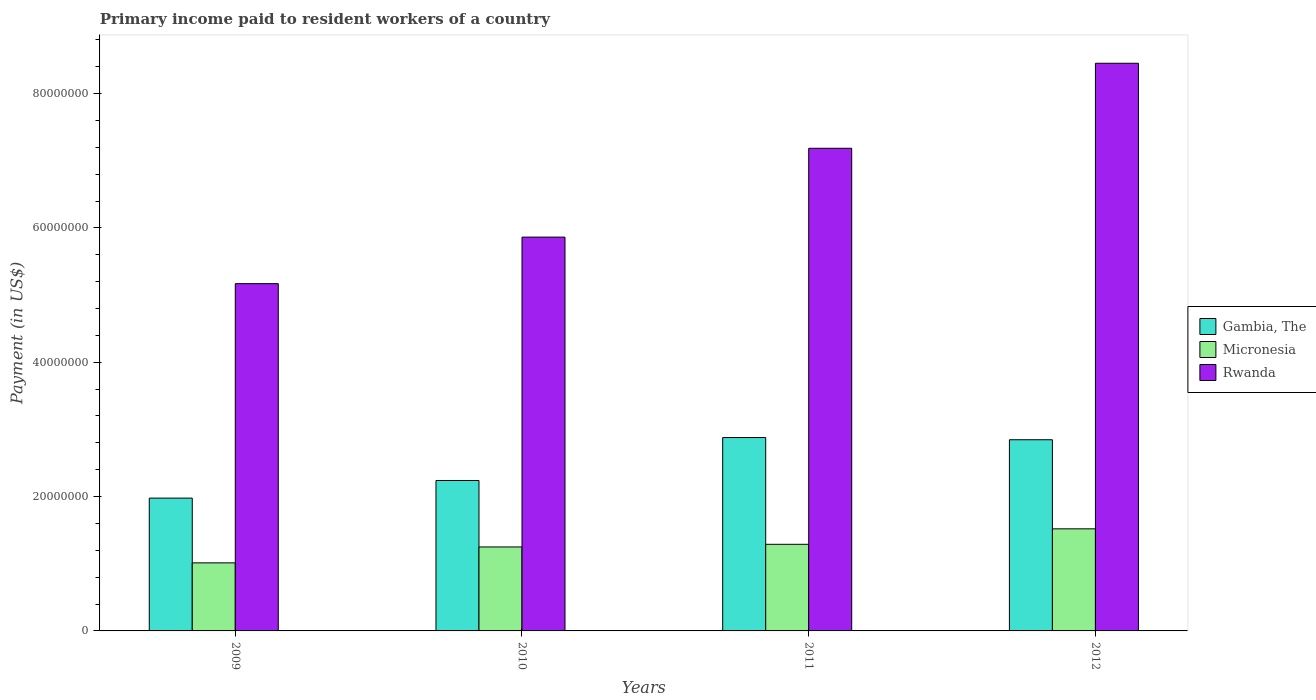Are the number of bars per tick equal to the number of legend labels?
Provide a short and direct response. Yes. Are the number of bars on each tick of the X-axis equal?
Make the answer very short. Yes. How many bars are there on the 1st tick from the right?
Your answer should be very brief. 3. In how many cases, is the number of bars for a given year not equal to the number of legend labels?
Ensure brevity in your answer.  0. What is the amount paid to workers in Rwanda in 2009?
Offer a very short reply. 5.17e+07. Across all years, what is the maximum amount paid to workers in Gambia, The?
Your response must be concise. 2.88e+07. Across all years, what is the minimum amount paid to workers in Micronesia?
Your answer should be compact. 1.01e+07. In which year was the amount paid to workers in Rwanda maximum?
Offer a terse response. 2012. What is the total amount paid to workers in Micronesia in the graph?
Your answer should be compact. 5.07e+07. What is the difference between the amount paid to workers in Gambia, The in 2010 and that in 2012?
Offer a very short reply. -6.07e+06. What is the difference between the amount paid to workers in Rwanda in 2011 and the amount paid to workers in Micronesia in 2009?
Keep it short and to the point. 6.17e+07. What is the average amount paid to workers in Rwanda per year?
Your answer should be compact. 6.67e+07. In the year 2011, what is the difference between the amount paid to workers in Rwanda and amount paid to workers in Gambia, The?
Your response must be concise. 4.31e+07. What is the ratio of the amount paid to workers in Micronesia in 2009 to that in 2010?
Provide a succinct answer. 0.81. What is the difference between the highest and the second highest amount paid to workers in Gambia, The?
Give a very brief answer. 3.26e+05. What is the difference between the highest and the lowest amount paid to workers in Micronesia?
Provide a short and direct response. 5.07e+06. In how many years, is the amount paid to workers in Rwanda greater than the average amount paid to workers in Rwanda taken over all years?
Your answer should be compact. 2. What does the 1st bar from the left in 2009 represents?
Offer a terse response. Gambia, The. What does the 1st bar from the right in 2011 represents?
Make the answer very short. Rwanda. Is it the case that in every year, the sum of the amount paid to workers in Rwanda and amount paid to workers in Micronesia is greater than the amount paid to workers in Gambia, The?
Your answer should be very brief. Yes. How many bars are there?
Make the answer very short. 12. How many years are there in the graph?
Give a very brief answer. 4. What is the difference between two consecutive major ticks on the Y-axis?
Ensure brevity in your answer.  2.00e+07. Does the graph contain grids?
Provide a short and direct response. No. How are the legend labels stacked?
Give a very brief answer. Vertical. What is the title of the graph?
Keep it short and to the point. Primary income paid to resident workers of a country. Does "Sweden" appear as one of the legend labels in the graph?
Provide a succinct answer. No. What is the label or title of the X-axis?
Offer a terse response. Years. What is the label or title of the Y-axis?
Make the answer very short. Payment (in US$). What is the Payment (in US$) in Gambia, The in 2009?
Your answer should be compact. 1.98e+07. What is the Payment (in US$) in Micronesia in 2009?
Provide a short and direct response. 1.01e+07. What is the Payment (in US$) of Rwanda in 2009?
Offer a very short reply. 5.17e+07. What is the Payment (in US$) in Gambia, The in 2010?
Your response must be concise. 2.24e+07. What is the Payment (in US$) of Micronesia in 2010?
Ensure brevity in your answer.  1.25e+07. What is the Payment (in US$) in Rwanda in 2010?
Keep it short and to the point. 5.86e+07. What is the Payment (in US$) of Gambia, The in 2011?
Provide a succinct answer. 2.88e+07. What is the Payment (in US$) of Micronesia in 2011?
Offer a terse response. 1.29e+07. What is the Payment (in US$) of Rwanda in 2011?
Make the answer very short. 7.19e+07. What is the Payment (in US$) in Gambia, The in 2012?
Your answer should be very brief. 2.85e+07. What is the Payment (in US$) in Micronesia in 2012?
Make the answer very short. 1.52e+07. What is the Payment (in US$) in Rwanda in 2012?
Provide a succinct answer. 8.45e+07. Across all years, what is the maximum Payment (in US$) of Gambia, The?
Offer a terse response. 2.88e+07. Across all years, what is the maximum Payment (in US$) in Micronesia?
Your response must be concise. 1.52e+07. Across all years, what is the maximum Payment (in US$) in Rwanda?
Provide a succinct answer. 8.45e+07. Across all years, what is the minimum Payment (in US$) of Gambia, The?
Your answer should be compact. 1.98e+07. Across all years, what is the minimum Payment (in US$) in Micronesia?
Offer a terse response. 1.01e+07. Across all years, what is the minimum Payment (in US$) of Rwanda?
Offer a terse response. 5.17e+07. What is the total Payment (in US$) in Gambia, The in the graph?
Give a very brief answer. 9.94e+07. What is the total Payment (in US$) in Micronesia in the graph?
Your answer should be very brief. 5.07e+07. What is the total Payment (in US$) in Rwanda in the graph?
Provide a short and direct response. 2.67e+08. What is the difference between the Payment (in US$) of Gambia, The in 2009 and that in 2010?
Your answer should be compact. -2.62e+06. What is the difference between the Payment (in US$) in Micronesia in 2009 and that in 2010?
Ensure brevity in your answer.  -2.37e+06. What is the difference between the Payment (in US$) in Rwanda in 2009 and that in 2010?
Make the answer very short. -6.93e+06. What is the difference between the Payment (in US$) in Gambia, The in 2009 and that in 2011?
Your response must be concise. -9.02e+06. What is the difference between the Payment (in US$) of Micronesia in 2009 and that in 2011?
Offer a terse response. -2.76e+06. What is the difference between the Payment (in US$) of Rwanda in 2009 and that in 2011?
Provide a short and direct response. -2.02e+07. What is the difference between the Payment (in US$) of Gambia, The in 2009 and that in 2012?
Your answer should be very brief. -8.69e+06. What is the difference between the Payment (in US$) of Micronesia in 2009 and that in 2012?
Ensure brevity in your answer.  -5.07e+06. What is the difference between the Payment (in US$) of Rwanda in 2009 and that in 2012?
Your answer should be compact. -3.28e+07. What is the difference between the Payment (in US$) of Gambia, The in 2010 and that in 2011?
Your answer should be compact. -6.40e+06. What is the difference between the Payment (in US$) of Micronesia in 2010 and that in 2011?
Provide a succinct answer. -3.94e+05. What is the difference between the Payment (in US$) in Rwanda in 2010 and that in 2011?
Your response must be concise. -1.32e+07. What is the difference between the Payment (in US$) in Gambia, The in 2010 and that in 2012?
Make the answer very short. -6.07e+06. What is the difference between the Payment (in US$) of Micronesia in 2010 and that in 2012?
Your answer should be compact. -2.70e+06. What is the difference between the Payment (in US$) of Rwanda in 2010 and that in 2012?
Keep it short and to the point. -2.59e+07. What is the difference between the Payment (in US$) of Gambia, The in 2011 and that in 2012?
Your response must be concise. 3.26e+05. What is the difference between the Payment (in US$) in Micronesia in 2011 and that in 2012?
Keep it short and to the point. -2.30e+06. What is the difference between the Payment (in US$) of Rwanda in 2011 and that in 2012?
Give a very brief answer. -1.27e+07. What is the difference between the Payment (in US$) of Gambia, The in 2009 and the Payment (in US$) of Micronesia in 2010?
Your answer should be compact. 7.27e+06. What is the difference between the Payment (in US$) of Gambia, The in 2009 and the Payment (in US$) of Rwanda in 2010?
Offer a terse response. -3.89e+07. What is the difference between the Payment (in US$) in Micronesia in 2009 and the Payment (in US$) in Rwanda in 2010?
Provide a short and direct response. -4.85e+07. What is the difference between the Payment (in US$) in Gambia, The in 2009 and the Payment (in US$) in Micronesia in 2011?
Your answer should be compact. 6.88e+06. What is the difference between the Payment (in US$) of Gambia, The in 2009 and the Payment (in US$) of Rwanda in 2011?
Your answer should be compact. -5.21e+07. What is the difference between the Payment (in US$) in Micronesia in 2009 and the Payment (in US$) in Rwanda in 2011?
Keep it short and to the point. -6.17e+07. What is the difference between the Payment (in US$) in Gambia, The in 2009 and the Payment (in US$) in Micronesia in 2012?
Provide a succinct answer. 4.57e+06. What is the difference between the Payment (in US$) in Gambia, The in 2009 and the Payment (in US$) in Rwanda in 2012?
Ensure brevity in your answer.  -6.47e+07. What is the difference between the Payment (in US$) of Micronesia in 2009 and the Payment (in US$) of Rwanda in 2012?
Make the answer very short. -7.44e+07. What is the difference between the Payment (in US$) of Gambia, The in 2010 and the Payment (in US$) of Micronesia in 2011?
Provide a short and direct response. 9.50e+06. What is the difference between the Payment (in US$) in Gambia, The in 2010 and the Payment (in US$) in Rwanda in 2011?
Make the answer very short. -4.95e+07. What is the difference between the Payment (in US$) of Micronesia in 2010 and the Payment (in US$) of Rwanda in 2011?
Make the answer very short. -5.94e+07. What is the difference between the Payment (in US$) of Gambia, The in 2010 and the Payment (in US$) of Micronesia in 2012?
Your answer should be compact. 7.20e+06. What is the difference between the Payment (in US$) of Gambia, The in 2010 and the Payment (in US$) of Rwanda in 2012?
Provide a short and direct response. -6.21e+07. What is the difference between the Payment (in US$) in Micronesia in 2010 and the Payment (in US$) in Rwanda in 2012?
Provide a succinct answer. -7.20e+07. What is the difference between the Payment (in US$) in Gambia, The in 2011 and the Payment (in US$) in Micronesia in 2012?
Your answer should be compact. 1.36e+07. What is the difference between the Payment (in US$) of Gambia, The in 2011 and the Payment (in US$) of Rwanda in 2012?
Provide a short and direct response. -5.57e+07. What is the difference between the Payment (in US$) of Micronesia in 2011 and the Payment (in US$) of Rwanda in 2012?
Offer a very short reply. -7.16e+07. What is the average Payment (in US$) in Gambia, The per year?
Your answer should be compact. 2.49e+07. What is the average Payment (in US$) in Micronesia per year?
Ensure brevity in your answer.  1.27e+07. What is the average Payment (in US$) in Rwanda per year?
Your answer should be compact. 6.67e+07. In the year 2009, what is the difference between the Payment (in US$) of Gambia, The and Payment (in US$) of Micronesia?
Your answer should be very brief. 9.64e+06. In the year 2009, what is the difference between the Payment (in US$) in Gambia, The and Payment (in US$) in Rwanda?
Your response must be concise. -3.19e+07. In the year 2009, what is the difference between the Payment (in US$) in Micronesia and Payment (in US$) in Rwanda?
Give a very brief answer. -4.16e+07. In the year 2010, what is the difference between the Payment (in US$) in Gambia, The and Payment (in US$) in Micronesia?
Make the answer very short. 9.89e+06. In the year 2010, what is the difference between the Payment (in US$) in Gambia, The and Payment (in US$) in Rwanda?
Keep it short and to the point. -3.62e+07. In the year 2010, what is the difference between the Payment (in US$) of Micronesia and Payment (in US$) of Rwanda?
Keep it short and to the point. -4.61e+07. In the year 2011, what is the difference between the Payment (in US$) of Gambia, The and Payment (in US$) of Micronesia?
Make the answer very short. 1.59e+07. In the year 2011, what is the difference between the Payment (in US$) of Gambia, The and Payment (in US$) of Rwanda?
Your answer should be compact. -4.31e+07. In the year 2011, what is the difference between the Payment (in US$) of Micronesia and Payment (in US$) of Rwanda?
Your answer should be compact. -5.90e+07. In the year 2012, what is the difference between the Payment (in US$) in Gambia, The and Payment (in US$) in Micronesia?
Offer a very short reply. 1.33e+07. In the year 2012, what is the difference between the Payment (in US$) in Gambia, The and Payment (in US$) in Rwanda?
Provide a succinct answer. -5.61e+07. In the year 2012, what is the difference between the Payment (in US$) of Micronesia and Payment (in US$) of Rwanda?
Make the answer very short. -6.93e+07. What is the ratio of the Payment (in US$) in Gambia, The in 2009 to that in 2010?
Ensure brevity in your answer.  0.88. What is the ratio of the Payment (in US$) of Micronesia in 2009 to that in 2010?
Keep it short and to the point. 0.81. What is the ratio of the Payment (in US$) in Rwanda in 2009 to that in 2010?
Your answer should be very brief. 0.88. What is the ratio of the Payment (in US$) in Gambia, The in 2009 to that in 2011?
Give a very brief answer. 0.69. What is the ratio of the Payment (in US$) of Micronesia in 2009 to that in 2011?
Your answer should be compact. 0.79. What is the ratio of the Payment (in US$) in Rwanda in 2009 to that in 2011?
Make the answer very short. 0.72. What is the ratio of the Payment (in US$) of Gambia, The in 2009 to that in 2012?
Your response must be concise. 0.69. What is the ratio of the Payment (in US$) in Micronesia in 2009 to that in 2012?
Provide a short and direct response. 0.67. What is the ratio of the Payment (in US$) in Rwanda in 2009 to that in 2012?
Offer a terse response. 0.61. What is the ratio of the Payment (in US$) in Gambia, The in 2010 to that in 2011?
Your answer should be very brief. 0.78. What is the ratio of the Payment (in US$) in Micronesia in 2010 to that in 2011?
Give a very brief answer. 0.97. What is the ratio of the Payment (in US$) of Rwanda in 2010 to that in 2011?
Your response must be concise. 0.82. What is the ratio of the Payment (in US$) in Gambia, The in 2010 to that in 2012?
Provide a succinct answer. 0.79. What is the ratio of the Payment (in US$) in Micronesia in 2010 to that in 2012?
Your answer should be compact. 0.82. What is the ratio of the Payment (in US$) in Rwanda in 2010 to that in 2012?
Your answer should be compact. 0.69. What is the ratio of the Payment (in US$) of Gambia, The in 2011 to that in 2012?
Keep it short and to the point. 1.01. What is the ratio of the Payment (in US$) of Micronesia in 2011 to that in 2012?
Ensure brevity in your answer.  0.85. What is the ratio of the Payment (in US$) in Rwanda in 2011 to that in 2012?
Provide a short and direct response. 0.85. What is the difference between the highest and the second highest Payment (in US$) of Gambia, The?
Your answer should be very brief. 3.26e+05. What is the difference between the highest and the second highest Payment (in US$) in Micronesia?
Provide a short and direct response. 2.30e+06. What is the difference between the highest and the second highest Payment (in US$) of Rwanda?
Make the answer very short. 1.27e+07. What is the difference between the highest and the lowest Payment (in US$) of Gambia, The?
Offer a terse response. 9.02e+06. What is the difference between the highest and the lowest Payment (in US$) of Micronesia?
Give a very brief answer. 5.07e+06. What is the difference between the highest and the lowest Payment (in US$) in Rwanda?
Your answer should be compact. 3.28e+07. 